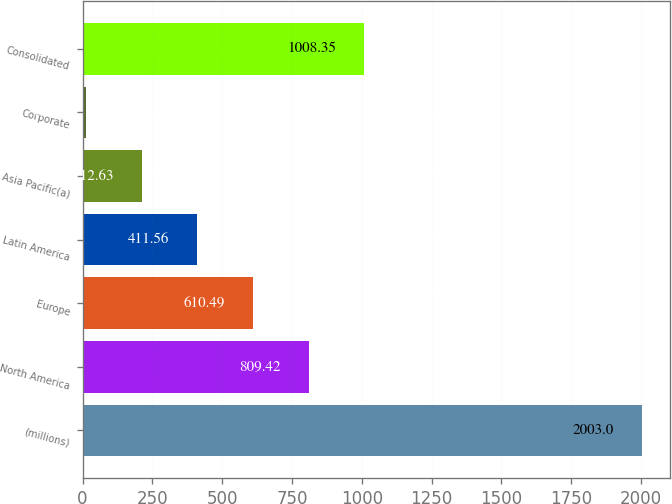Convert chart. <chart><loc_0><loc_0><loc_500><loc_500><bar_chart><fcel>(millions)<fcel>North America<fcel>Europe<fcel>Latin America<fcel>Asia Pacific(a)<fcel>Corporate<fcel>Consolidated<nl><fcel>2003<fcel>809.42<fcel>610.49<fcel>411.56<fcel>212.63<fcel>13.7<fcel>1008.35<nl></chart> 